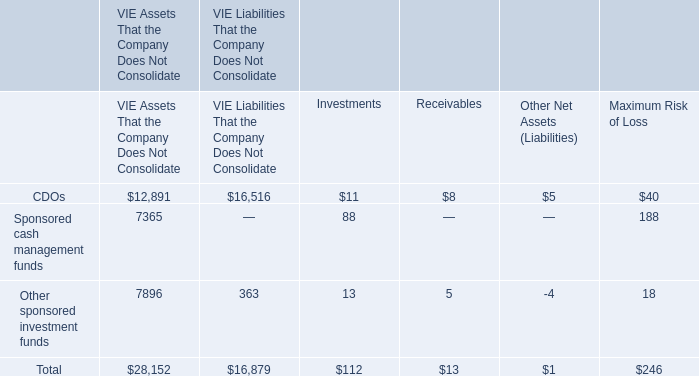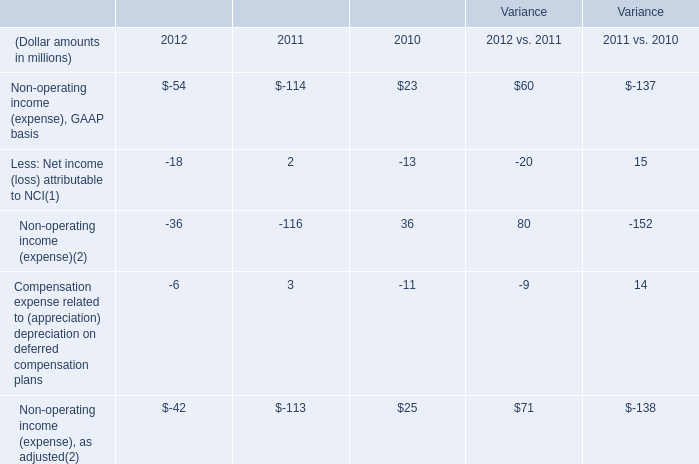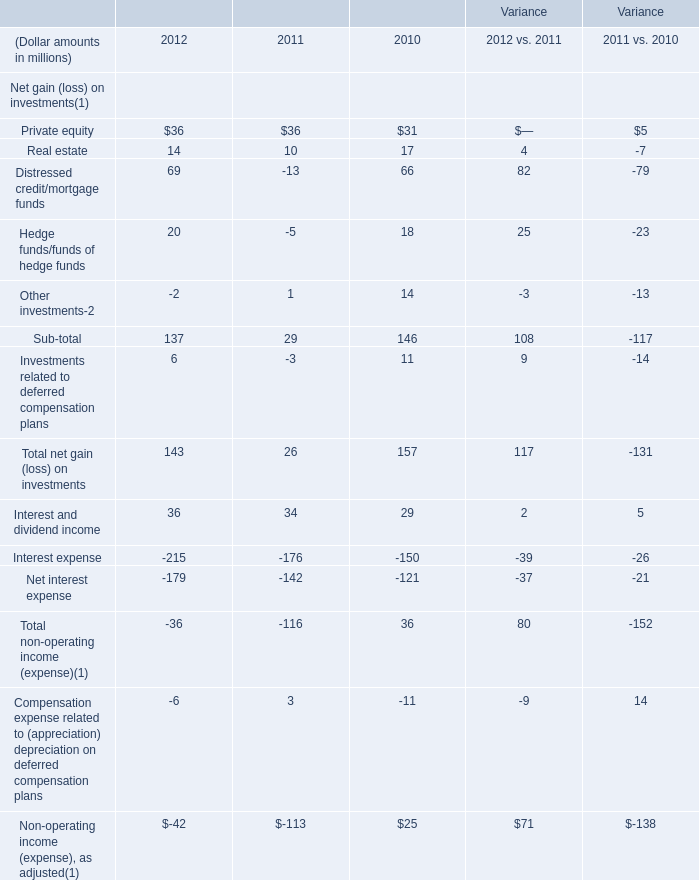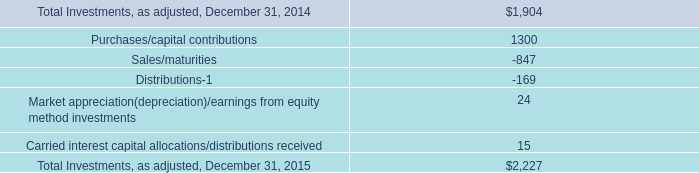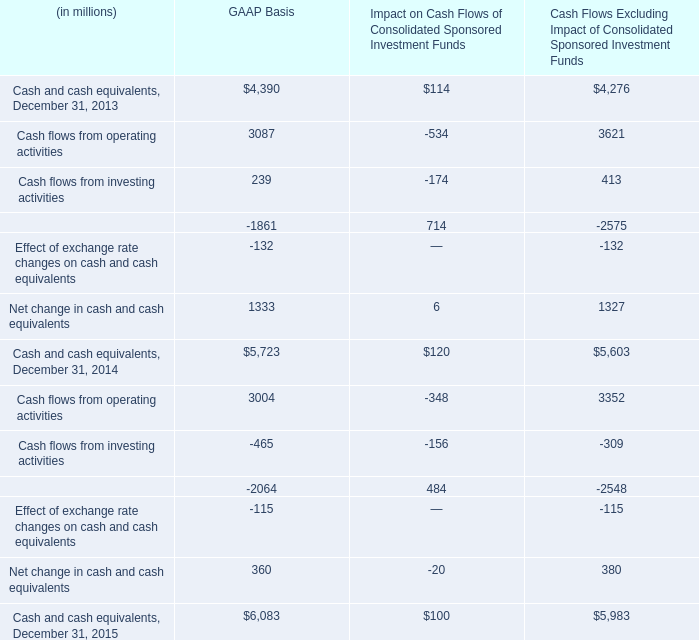The total amount of which section ranks first in 2012? 
Answer: Compensation expense related to (appreciation) depreciation on deferred compensation plans. 